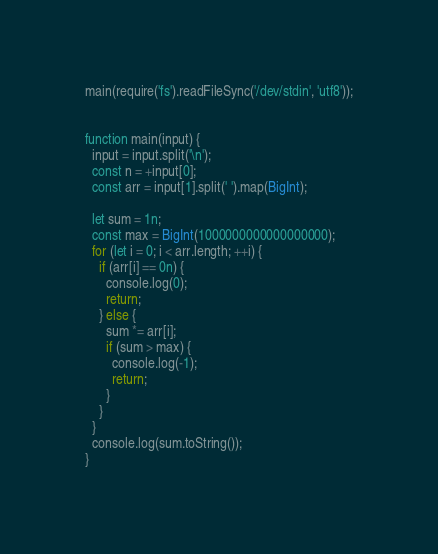<code> <loc_0><loc_0><loc_500><loc_500><_JavaScript_>main(require('fs').readFileSync('/dev/stdin', 'utf8'));


function main(input) {
  input = input.split('\n');
  const n = +input[0];
  const arr = input[1].split(' ').map(BigInt);

  let sum = 1n;
  const max = BigInt(1000000000000000000);
  for (let i = 0; i < arr.length; ++i) {
    if (arr[i] == 0n) {
      console.log(0);
      return;
    } else {
      sum *= arr[i];
      if (sum > max) {
        console.log(-1);
        return;
      }
    }
  }
  console.log(sum.toString());
}
</code> 